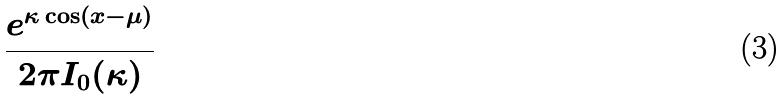<formula> <loc_0><loc_0><loc_500><loc_500>\frac { e ^ { \kappa \cos ( x - \mu ) } } { 2 \pi I _ { 0 } ( \kappa ) }</formula> 